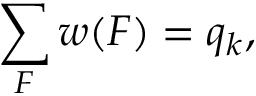<formula> <loc_0><loc_0><loc_500><loc_500>\sum _ { F } w ( F ) = q _ { k } ,</formula> 